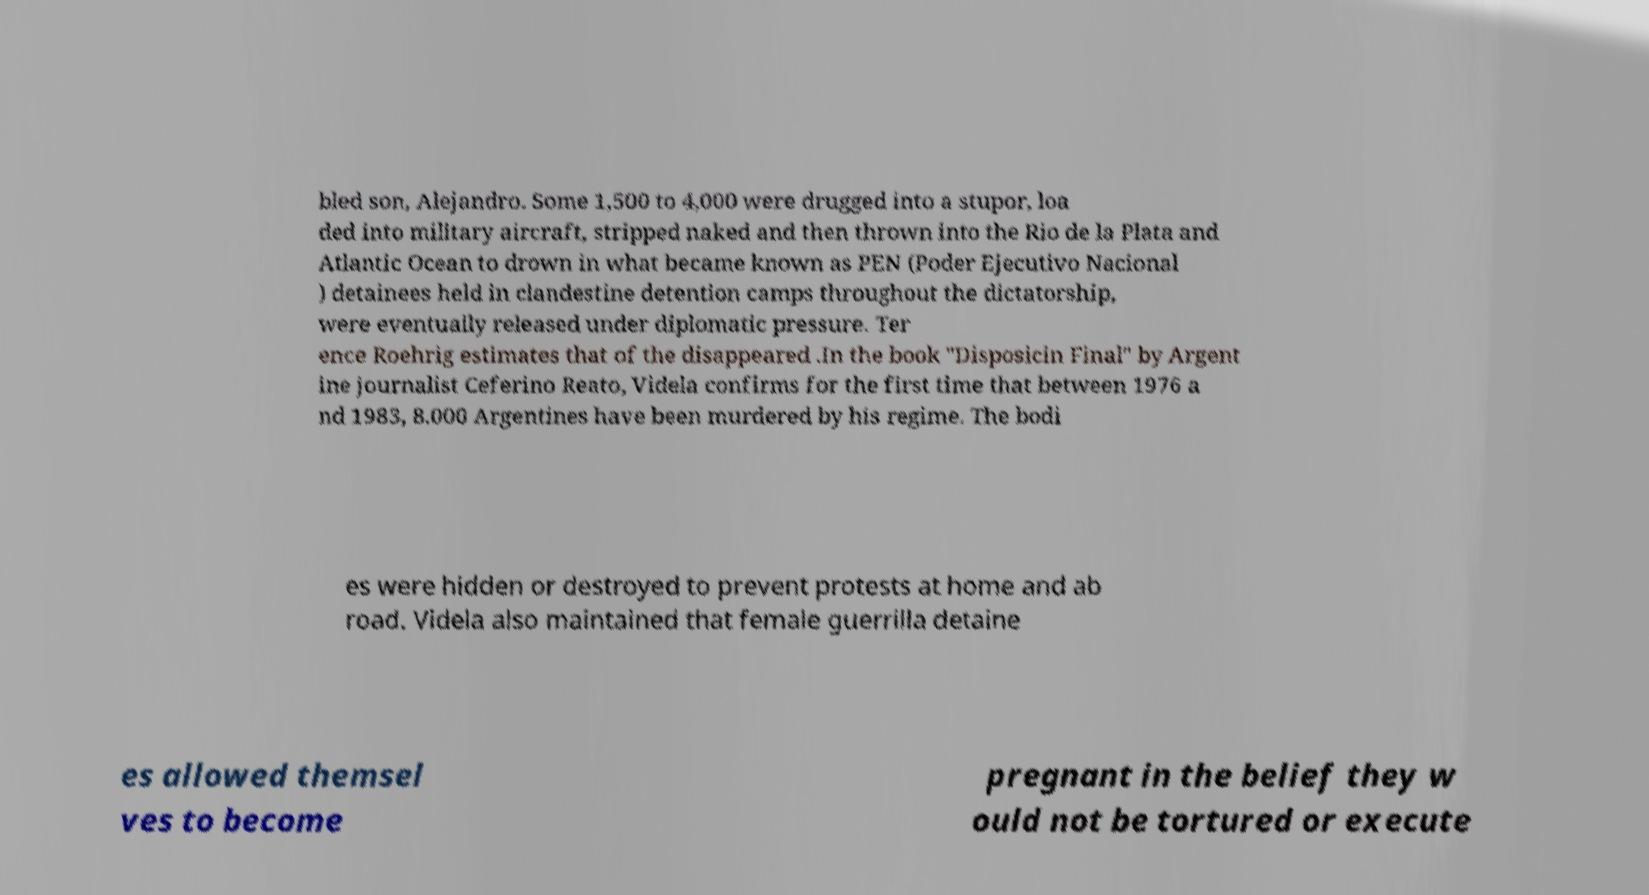There's text embedded in this image that I need extracted. Can you transcribe it verbatim? bled son, Alejandro. Some 1,500 to 4,000 were drugged into a stupor, loa ded into military aircraft, stripped naked and then thrown into the Rio de la Plata and Atlantic Ocean to drown in what became known as PEN (Poder Ejecutivo Nacional ) detainees held in clandestine detention camps throughout the dictatorship, were eventually released under diplomatic pressure. Ter ence Roehrig estimates that of the disappeared .In the book "Disposicin Final" by Argent ine journalist Ceferino Reato, Videla confirms for the first time that between 1976 a nd 1983, 8.000 Argentines have been murdered by his regime. The bodi es were hidden or destroyed to prevent protests at home and ab road. Videla also maintained that female guerrilla detaine es allowed themsel ves to become pregnant in the belief they w ould not be tortured or execute 